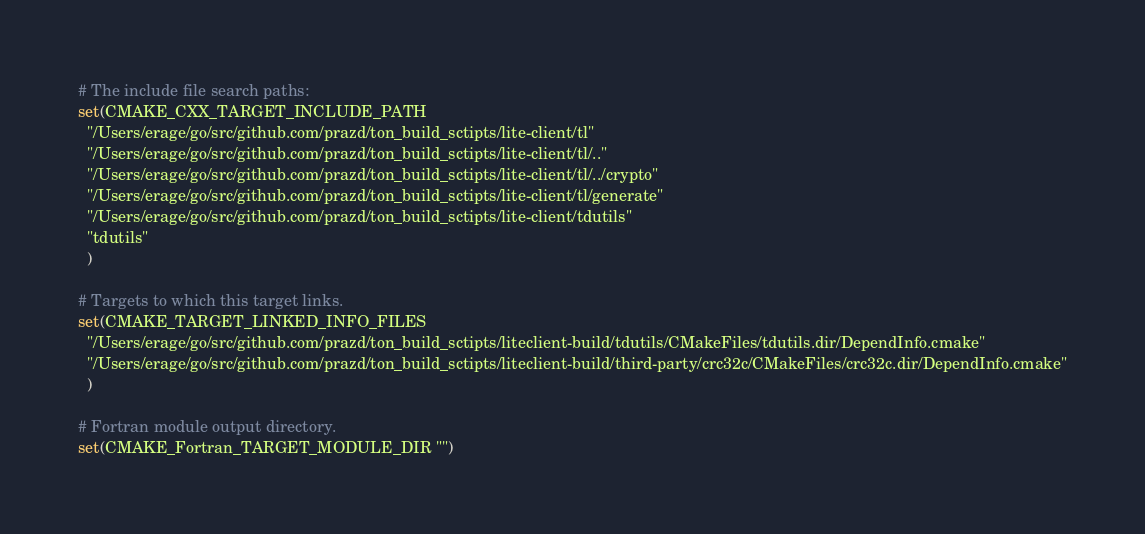Convert code to text. <code><loc_0><loc_0><loc_500><loc_500><_CMake_>
# The include file search paths:
set(CMAKE_CXX_TARGET_INCLUDE_PATH
  "/Users/erage/go/src/github.com/prazd/ton_build_sctipts/lite-client/tl"
  "/Users/erage/go/src/github.com/prazd/ton_build_sctipts/lite-client/tl/.."
  "/Users/erage/go/src/github.com/prazd/ton_build_sctipts/lite-client/tl/../crypto"
  "/Users/erage/go/src/github.com/prazd/ton_build_sctipts/lite-client/tl/generate"
  "/Users/erage/go/src/github.com/prazd/ton_build_sctipts/lite-client/tdutils"
  "tdutils"
  )

# Targets to which this target links.
set(CMAKE_TARGET_LINKED_INFO_FILES
  "/Users/erage/go/src/github.com/prazd/ton_build_sctipts/liteclient-build/tdutils/CMakeFiles/tdutils.dir/DependInfo.cmake"
  "/Users/erage/go/src/github.com/prazd/ton_build_sctipts/liteclient-build/third-party/crc32c/CMakeFiles/crc32c.dir/DependInfo.cmake"
  )

# Fortran module output directory.
set(CMAKE_Fortran_TARGET_MODULE_DIR "")
</code> 